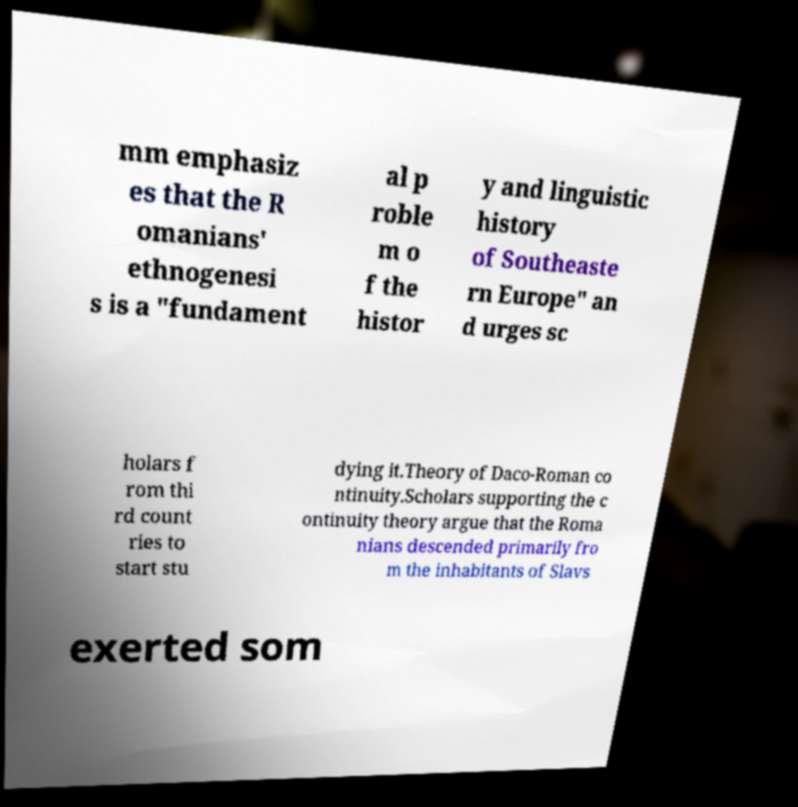Please identify and transcribe the text found in this image. mm emphasiz es that the R omanians' ethnogenesi s is a "fundament al p roble m o f the histor y and linguistic history of Southeaste rn Europe" an d urges sc holars f rom thi rd count ries to start stu dying it.Theory of Daco-Roman co ntinuity.Scholars supporting the c ontinuity theory argue that the Roma nians descended primarily fro m the inhabitants of Slavs exerted som 